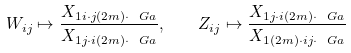Convert formula to latex. <formula><loc_0><loc_0><loc_500><loc_500>W _ { i j } \mapsto \frac { X _ { 1 i \cdot j ( 2 m ) \cdot \ G a } } { X _ { 1 j \cdot i ( 2 m ) \cdot \ G a } } , \quad Z _ { i j } \mapsto \frac { X _ { 1 j \cdot i ( 2 m ) \cdot \ G a } } { X _ { 1 ( 2 m ) \cdot i j \cdot \ G a } }</formula> 